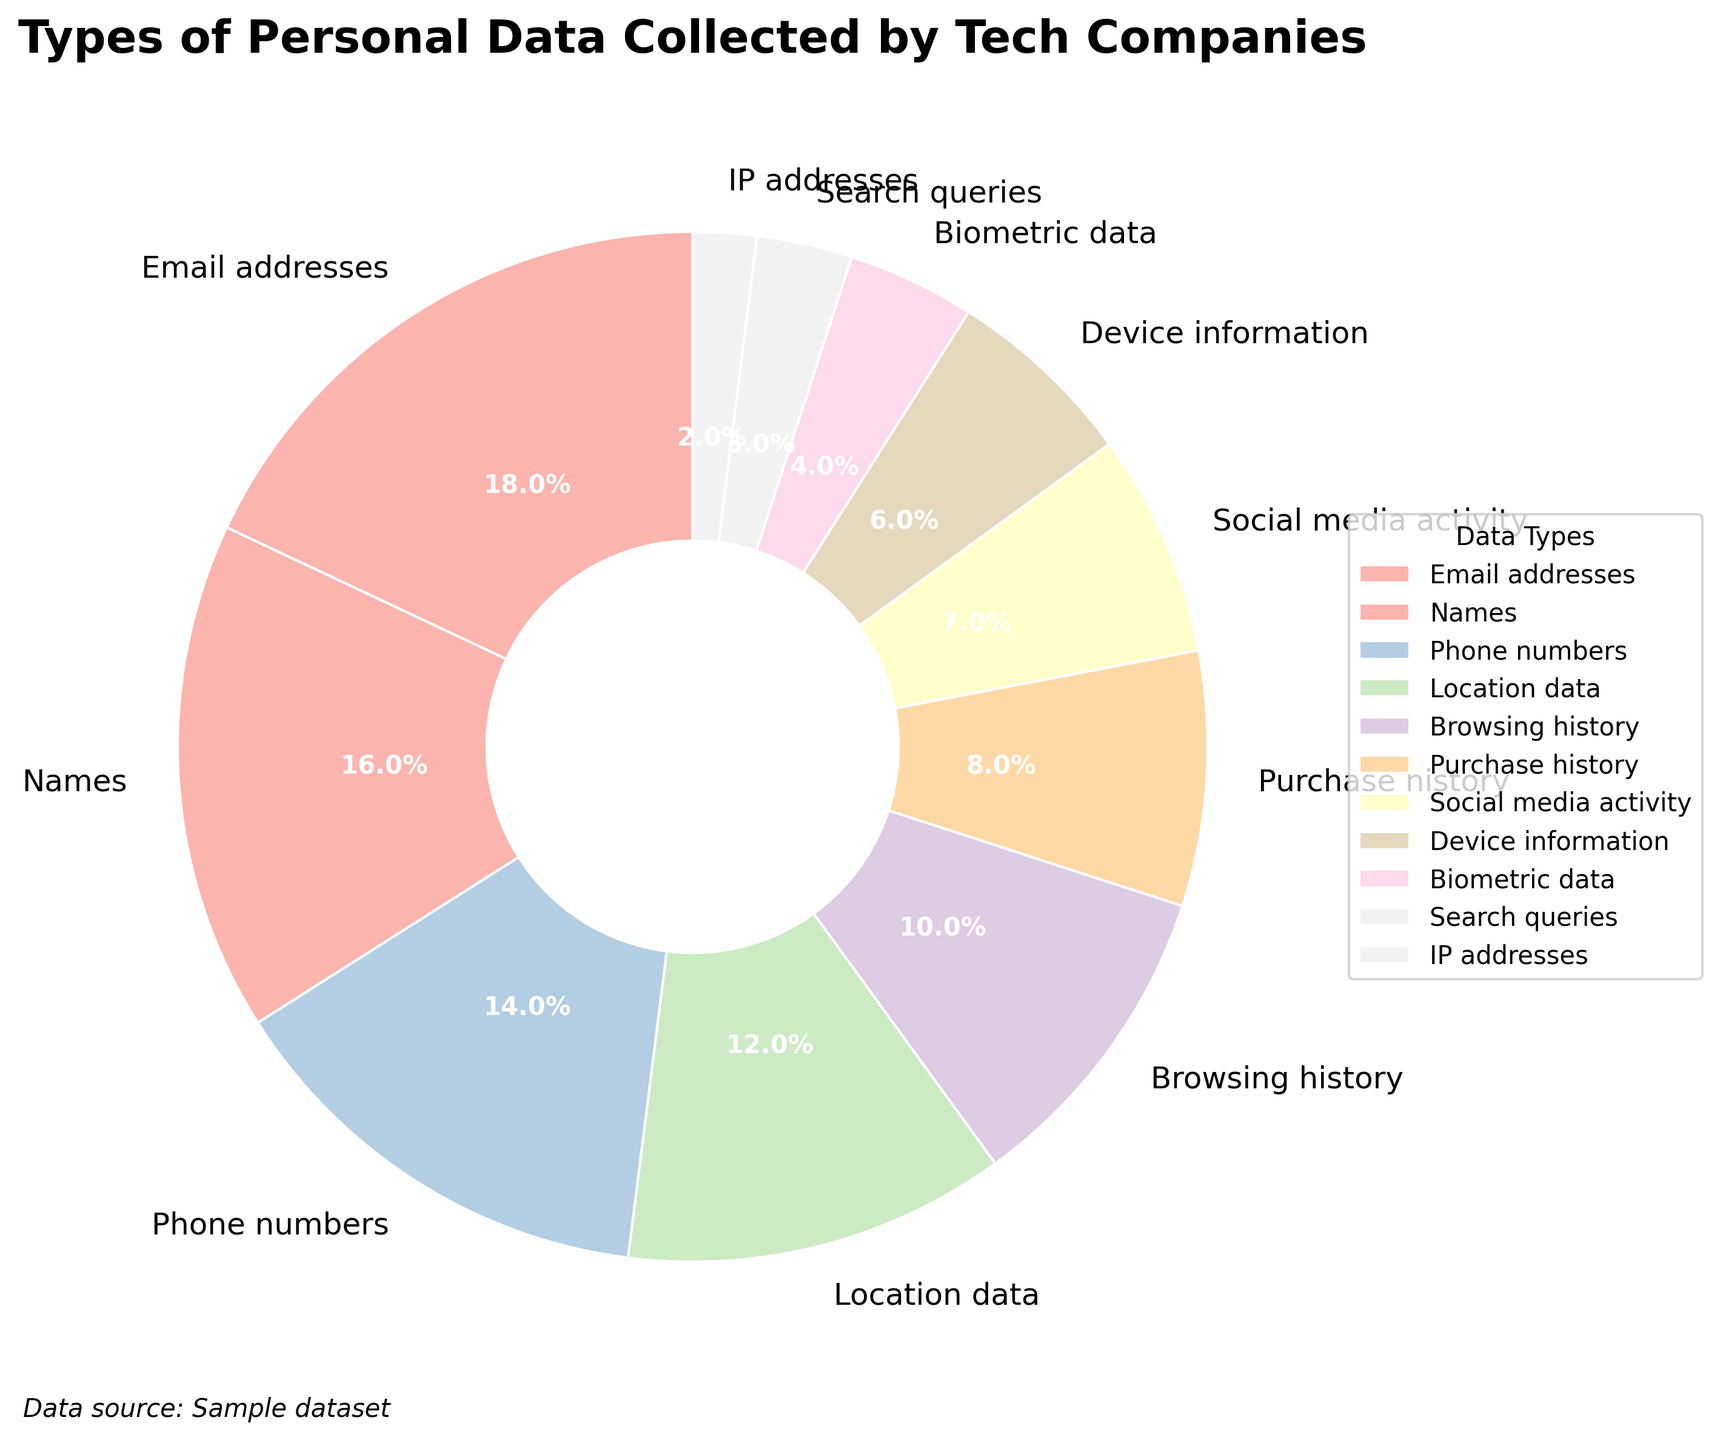What is the most commonly collected type of personal data according to the pie chart? The pie chart visually shows that "Email addresses" occupy the largest segment.
Answer: Email addresses Which type of personal data is collected more, "Location data" or "Social media activity"? By observing the pie chart, it is clear that the segment for "Location data" is larger compared to the segment for "Social media activity".
Answer: Location data What is the combined percentage of "Email addresses", "Names", and "Phone numbers" collected by tech companies? The percentages for "Email addresses", "Names", and "Phone numbers" are 18%, 16%, and 14% respectively. Summing them up gives 18% + 16% + 14% = 48%.
Answer: 48% How does the percentage of "Browsing history" compare to that of "Device information"? The pie chart shows that the segment for "Browsing history" is visibly larger than the segment for "Device information", specifically, 10% compared to 6%.
Answer: Browsing history Which three types of personal data have the smallest shares in the pie chart? The smallest segments in the pie chart correspond to the percentages 4%, 3%, and 2% which represent "Biometric data", "Search queries", and "IP addresses" respectively.
Answer: Biometric data, Search queries, IP addresses What percentage of data is categorized under "Phone numbers" and "Location data" together? The percentages for "Phone numbers" and "Location data" are 14% and 12% respectively. Summing these up gives 14% + 12% = 26%.
Answer: 26% Is the percentage of "Purchase history" more or less than that of "Social media activity" and by how much? The chart shows "Purchase history" at 8% and "Social media activity" at 7%. The difference is 8% - 7% = 1%.
Answer: 1% Are "Email addresses" and "Names" combined collected more than "Browsing history" and "Purchase history" combined? If yes, by how much? "Email addresses" and "Names" add up to 34% (18% + 16%), while "Browsing history" and "Purchase history" sum to 18% (10% + 8%). The combined percentage for "Email addresses" and "Names" is 34% - 18% = 16% more.
Answer: 16% What can be inferred about the collection of biometric data compared to phone numbers and location data? Biometric data is collected significantly less than phone numbers and location data. The chart attributes only 4% to biometric data, compared to 14% for phone numbers and 12% for location data.
Answer: Collected significantly less Based on the chart, which type of data is collected the least and what percentage does it represent? The chart indicates that "IP addresses" have the smallest segment, representing 2%.
Answer: IP addresses representing 2% 